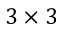Convert formula to latex. <formula><loc_0><loc_0><loc_500><loc_500>3 \times 3</formula> 